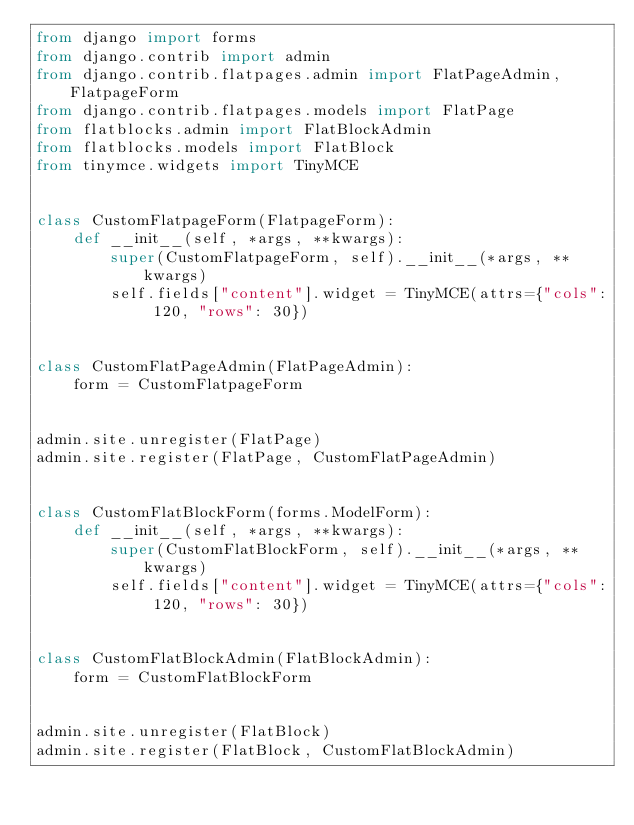Convert code to text. <code><loc_0><loc_0><loc_500><loc_500><_Python_>from django import forms
from django.contrib import admin
from django.contrib.flatpages.admin import FlatPageAdmin, FlatpageForm
from django.contrib.flatpages.models import FlatPage
from flatblocks.admin import FlatBlockAdmin
from flatblocks.models import FlatBlock
from tinymce.widgets import TinyMCE


class CustomFlatpageForm(FlatpageForm):
    def __init__(self, *args, **kwargs):
        super(CustomFlatpageForm, self).__init__(*args, **kwargs)
        self.fields["content"].widget = TinyMCE(attrs={"cols": 120, "rows": 30})


class CustomFlatPageAdmin(FlatPageAdmin):
    form = CustomFlatpageForm


admin.site.unregister(FlatPage)
admin.site.register(FlatPage, CustomFlatPageAdmin)


class CustomFlatBlockForm(forms.ModelForm):
    def __init__(self, *args, **kwargs):
        super(CustomFlatBlockForm, self).__init__(*args, **kwargs)
        self.fields["content"].widget = TinyMCE(attrs={"cols": 120, "rows": 30})


class CustomFlatBlockAdmin(FlatBlockAdmin):
    form = CustomFlatBlockForm


admin.site.unregister(FlatBlock)
admin.site.register(FlatBlock, CustomFlatBlockAdmin)
</code> 